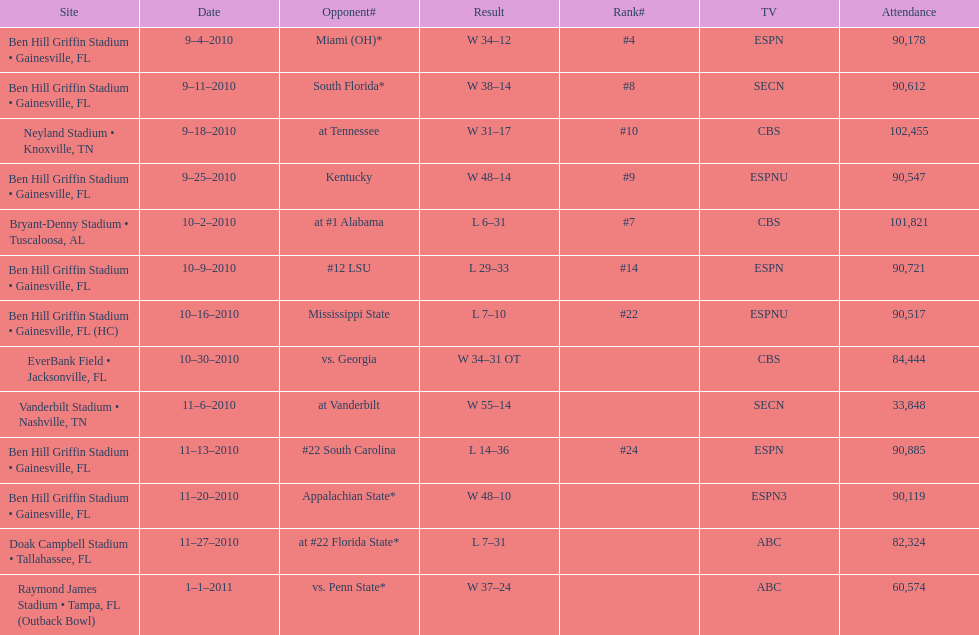How many games did the university of florida win by at least 10 points? 7. 